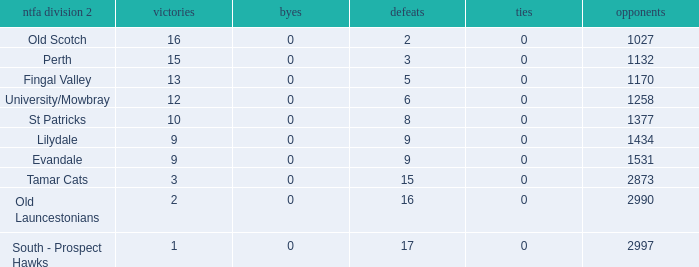What is the lowest number of draws of the NTFA Div 2 Lilydale? 0.0. 